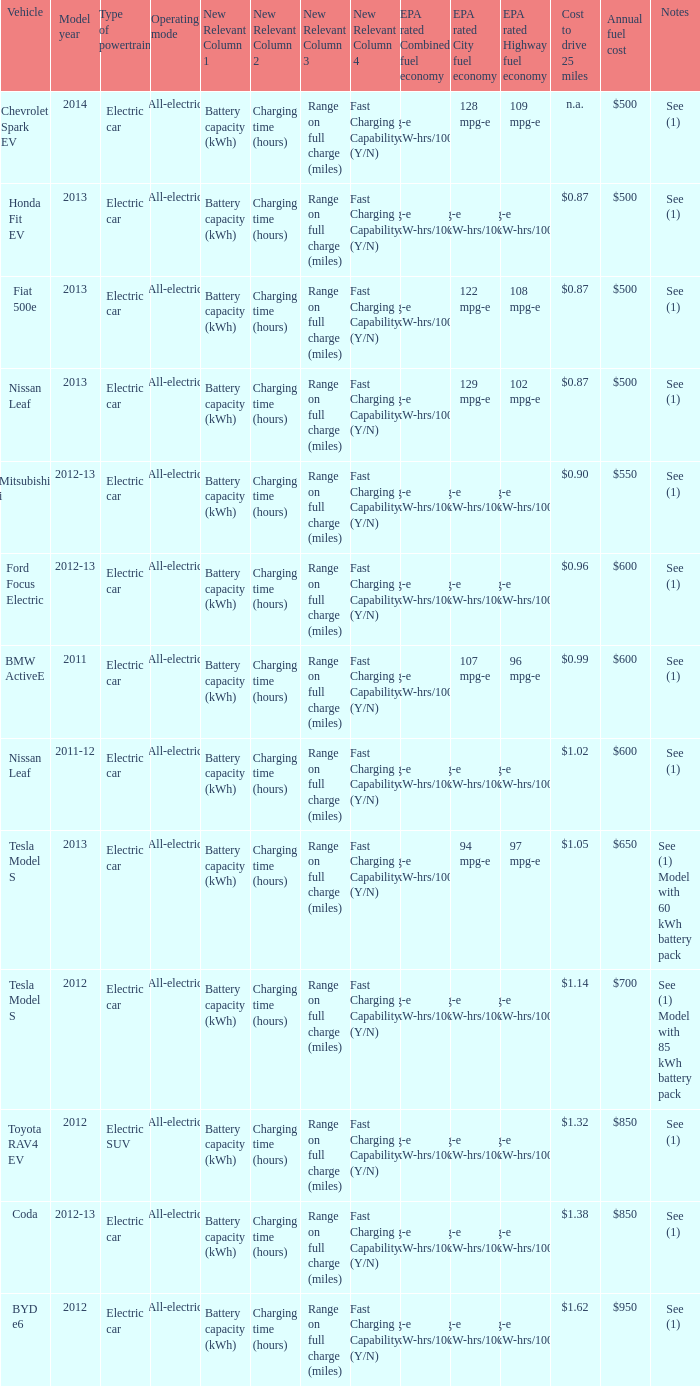What is the epa highway fuel economy for an electric suv? 74 mpg-e (46kW-hrs/100mi). 